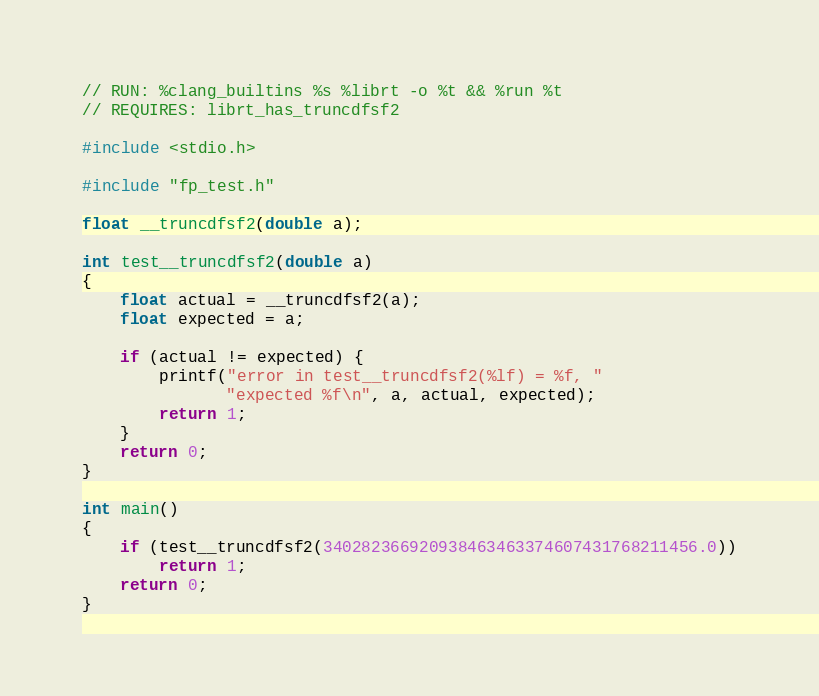<code> <loc_0><loc_0><loc_500><loc_500><_C_>// RUN: %clang_builtins %s %librt -o %t && %run %t
// REQUIRES: librt_has_truncdfsf2

#include <stdio.h>

#include "fp_test.h"

float __truncdfsf2(double a);

int test__truncdfsf2(double a)
{
    float actual = __truncdfsf2(a);
    float expected = a;

    if (actual != expected) {
        printf("error in test__truncdfsf2(%lf) = %f, "
               "expected %f\n", a, actual, expected);
        return 1;
    }
    return 0;
}

int main()
{
    if (test__truncdfsf2(340282366920938463463374607431768211456.0))
        return 1;
    return 0;
}
</code> 